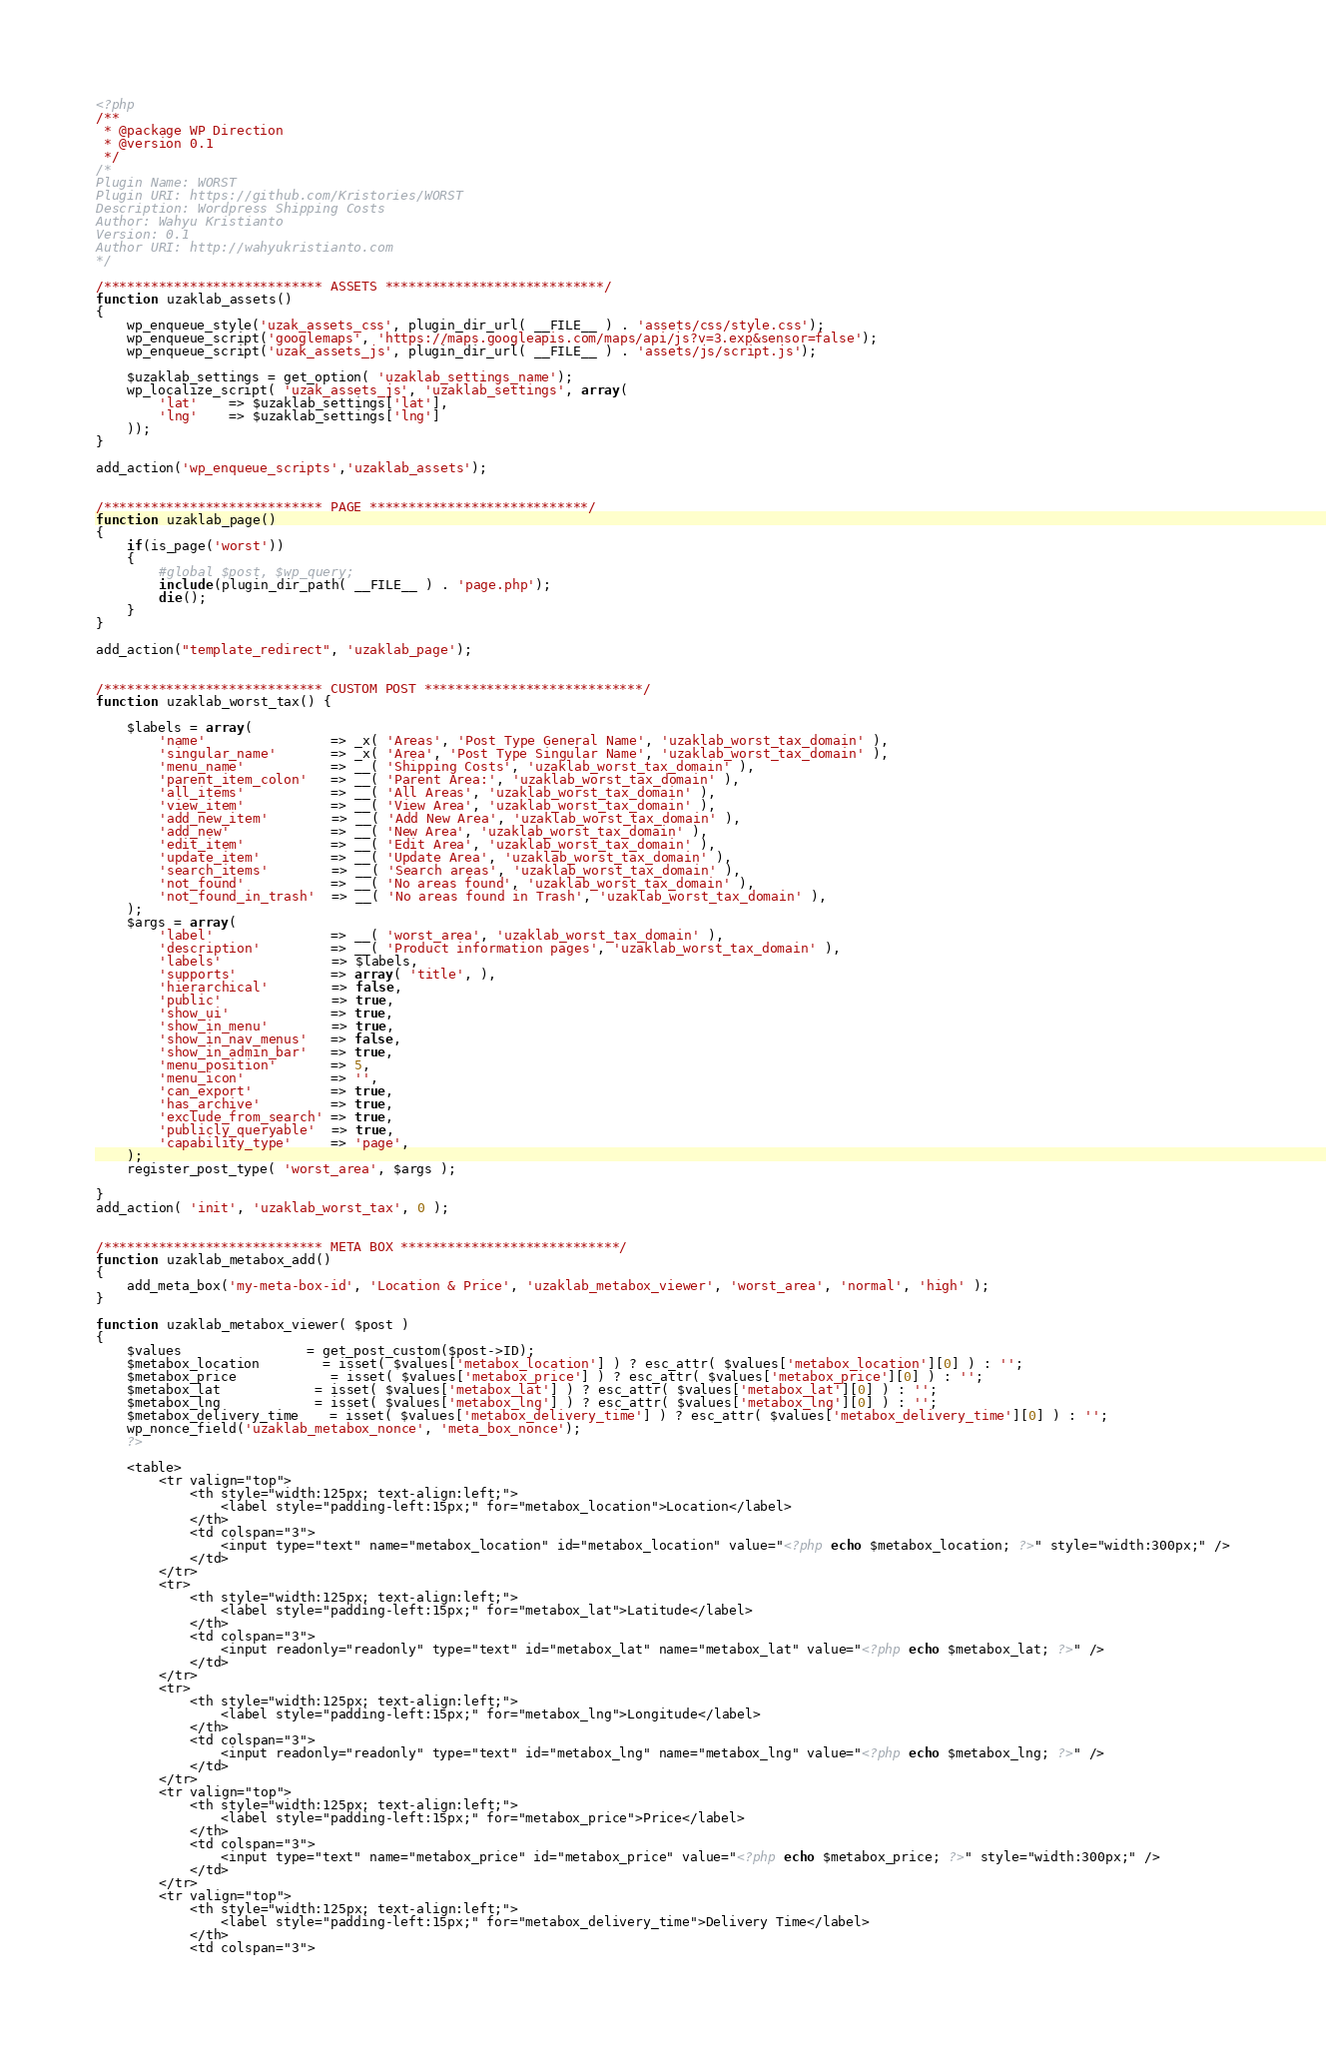Convert code to text. <code><loc_0><loc_0><loc_500><loc_500><_PHP_><?php
/**
 * @package WP Direction
 * @version 0.1
 */
/*
Plugin Name: WORST
Plugin URI: https://github.com/Kristories/WORST
Description: Wordpress Shipping Costs
Author: Wahyu Kristianto
Version: 0.1
Author URI: http://wahyukristianto.com
*/

/**************************** ASSETS ****************************/
function uzaklab_assets()
{
	wp_enqueue_style('uzak_assets_css', plugin_dir_url( __FILE__ ) . 'assets/css/style.css');
	wp_enqueue_script('googlemaps', 'https://maps.googleapis.com/maps/api/js?v=3.exp&sensor=false');
	wp_enqueue_script('uzak_assets_js', plugin_dir_url( __FILE__ ) . 'assets/js/script.js');

	$uzaklab_settings = get_option( 'uzaklab_settings_name');
	wp_localize_script( 'uzak_assets_js', 'uzaklab_settings', array(
		'lat' 	=> $uzaklab_settings['lat'],
		'lng'	=> $uzaklab_settings['lng']
	));
}

add_action('wp_enqueue_scripts','uzaklab_assets');


/**************************** PAGE ****************************/
function uzaklab_page()
{
	if(is_page('worst'))
	{
		#global $post, $wp_query;
		include(plugin_dir_path( __FILE__ ) . 'page.php');
		die();
	}
}

add_action("template_redirect", 'uzaklab_page');


/**************************** CUSTOM POST ****************************/
function uzaklab_worst_tax() {

	$labels = array(
		'name'                => _x( 'Areas', 'Post Type General Name', 'uzaklab_worst_tax_domain' ),
		'singular_name'       => _x( 'Area', 'Post Type Singular Name', 'uzaklab_worst_tax_domain' ),
		'menu_name'           => __( 'Shipping Costs', 'uzaklab_worst_tax_domain' ),
		'parent_item_colon'   => __( 'Parent Area:', 'uzaklab_worst_tax_domain' ),
		'all_items'           => __( 'All Areas', 'uzaklab_worst_tax_domain' ),
		'view_item'           => __( 'View Area', 'uzaklab_worst_tax_domain' ),
		'add_new_item'        => __( 'Add New Area', 'uzaklab_worst_tax_domain' ),
		'add_new'             => __( 'New Area', 'uzaklab_worst_tax_domain' ),
		'edit_item'           => __( 'Edit Area', 'uzaklab_worst_tax_domain' ),
		'update_item'         => __( 'Update Area', 'uzaklab_worst_tax_domain' ),
		'search_items'        => __( 'Search areas', 'uzaklab_worst_tax_domain' ),
		'not_found'           => __( 'No areas found', 'uzaklab_worst_tax_domain' ),
		'not_found_in_trash'  => __( 'No areas found in Trash', 'uzaklab_worst_tax_domain' ),
	);
	$args = array(
		'label'               => __( 'worst_area', 'uzaklab_worst_tax_domain' ),
		'description'         => __( 'Product information pages', 'uzaklab_worst_tax_domain' ),
		'labels'              => $labels,
		'supports'            => array( 'title', ),
		'hierarchical'        => false,
		'public'              => true,
		'show_ui'             => true,
		'show_in_menu'        => true,
		'show_in_nav_menus'   => false,
		'show_in_admin_bar'   => true,
		'menu_position'       => 5,
		'menu_icon'           => '',
		'can_export'          => true,
		'has_archive'         => true,
		'exclude_from_search' => true,
		'publicly_queryable'  => true,
		'capability_type'     => 'page',
	);
	register_post_type( 'worst_area', $args );

}
add_action( 'init', 'uzaklab_worst_tax', 0 );


/**************************** META BOX ****************************/
function uzaklab_metabox_add()
{
	add_meta_box('my-meta-box-id', 'Location & Price', 'uzaklab_metabox_viewer', 'worst_area', 'normal', 'high' );
}

function uzaklab_metabox_viewer( $post )
{
	$values 				= get_post_custom($post->ID);
	$metabox_location 		= isset( $values['metabox_location'] ) ? esc_attr( $values['metabox_location'][0] ) : '';
	$metabox_price 			= isset( $values['metabox_price'] ) ? esc_attr( $values['metabox_price'][0] ) : '';
	$metabox_lat 			= isset( $values['metabox_lat'] ) ? esc_attr( $values['metabox_lat'][0] ) : '';
	$metabox_lng 			= isset( $values['metabox_lng'] ) ? esc_attr( $values['metabox_lng'][0] ) : '';
	$metabox_delivery_time	= isset( $values['metabox_delivery_time'] ) ? esc_attr( $values['metabox_delivery_time'][0] ) : '';
	wp_nonce_field('uzaklab_metabox_nonce', 'meta_box_nonce');
	?>

	<table>  
		<tr valign="top">
			<th style="width:125px; text-align:left;">
				<label style="padding-left:15px;" for="metabox_location">Location</label>
			</th>
			<td colspan="3">
				<input type="text" name="metabox_location" id="metabox_location" value="<?php echo $metabox_location; ?>" style="width:300px;" />
			</td>
		</tr>
		<tr>
			<th style="width:125px; text-align:left;">
				<label style="padding-left:15px;" for="metabox_lat">Latitude</label>
			</th>
			<td colspan="3">
				<input readonly="readonly" type="text" id="metabox_lat" name="metabox_lat" value="<?php echo $metabox_lat; ?>" />
			</td>
		</tr>
		<tr>
			<th style="width:125px; text-align:left;">
				<label style="padding-left:15px;" for="metabox_lng">Longitude</label>
			</th>
			<td colspan="3">
				<input readonly="readonly" type="text" id="metabox_lng" name="metabox_lng" value="<?php echo $metabox_lng; ?>" />
			</td>
		</tr>
		<tr valign="top">
			<th style="width:125px; text-align:left;">
				<label style="padding-left:15px;" for="metabox_price">Price</label>
			</th>
			<td colspan="3">
				<input type="text" name="metabox_price" id="metabox_price" value="<?php echo $metabox_price; ?>" style="width:300px;" />
			</td>
		</tr>
		<tr valign="top">
			<th style="width:125px; text-align:left;">
				<label style="padding-left:15px;" for="metabox_delivery_time">Delivery Time</label>
			</th>
			<td colspan="3"></code> 